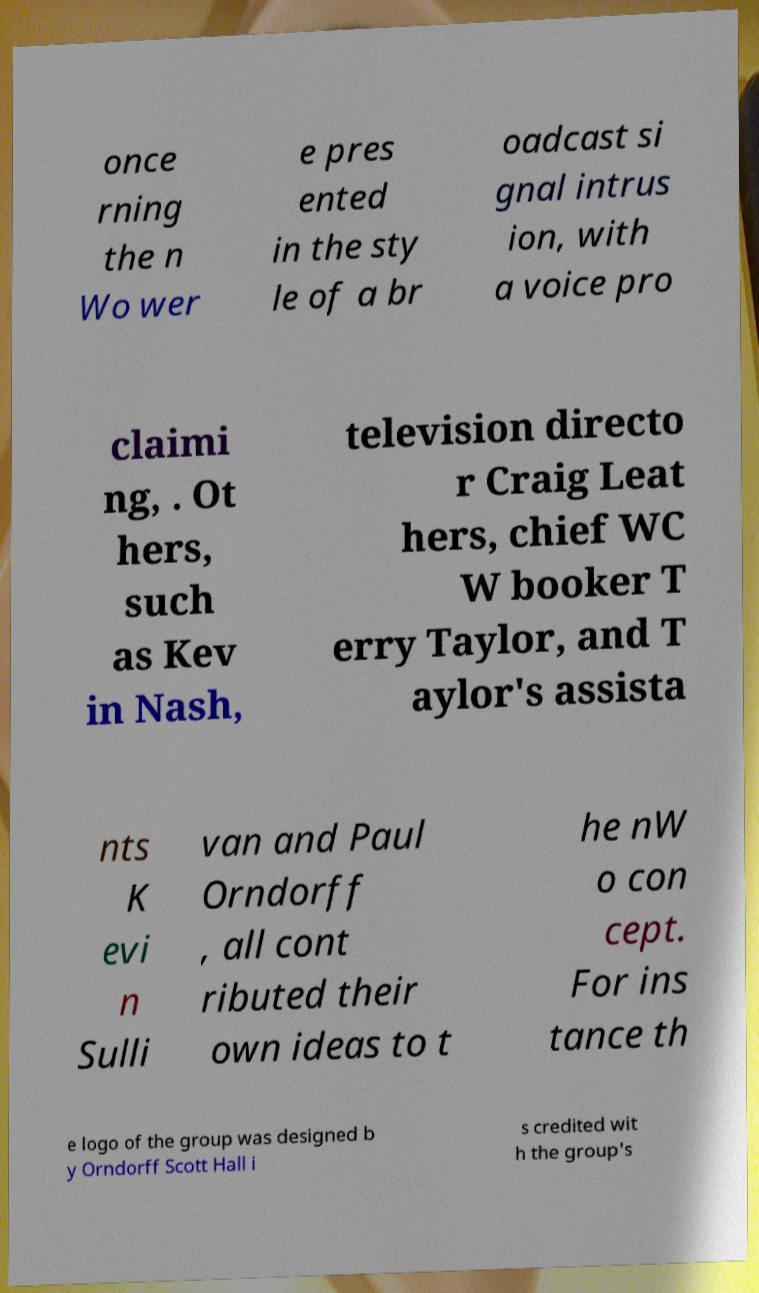Could you assist in decoding the text presented in this image and type it out clearly? once rning the n Wo wer e pres ented in the sty le of a br oadcast si gnal intrus ion, with a voice pro claimi ng, . Ot hers, such as Kev in Nash, television directo r Craig Leat hers, chief WC W booker T erry Taylor, and T aylor's assista nts K evi n Sulli van and Paul Orndorff , all cont ributed their own ideas to t he nW o con cept. For ins tance th e logo of the group was designed b y Orndorff Scott Hall i s credited wit h the group's 